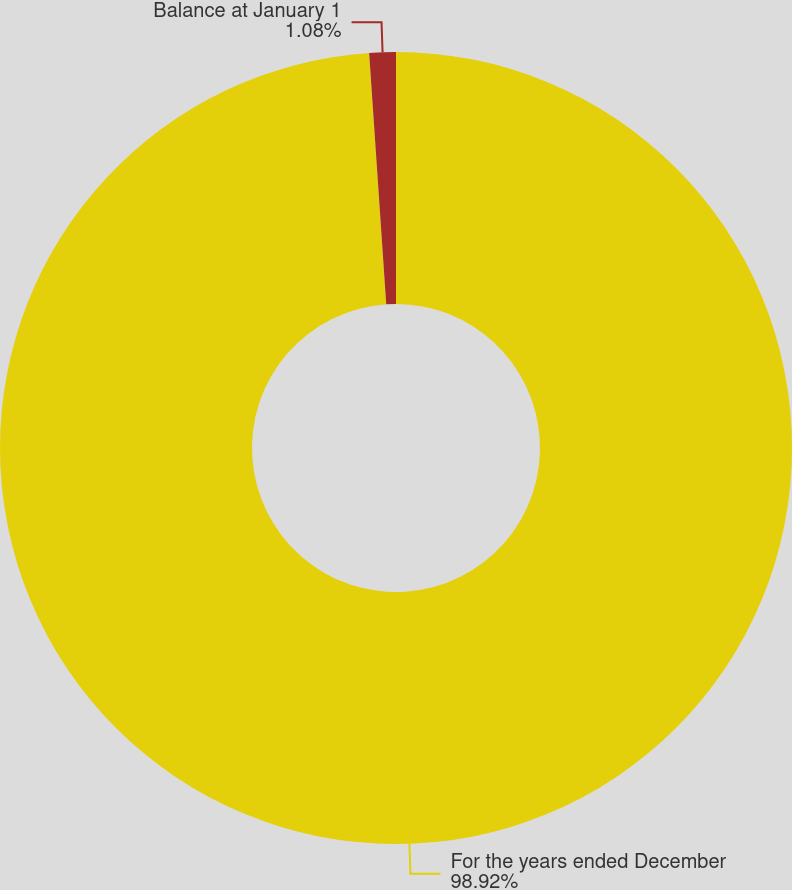Convert chart to OTSL. <chart><loc_0><loc_0><loc_500><loc_500><pie_chart><fcel>For the years ended December<fcel>Balance at January 1<nl><fcel>98.92%<fcel>1.08%<nl></chart> 